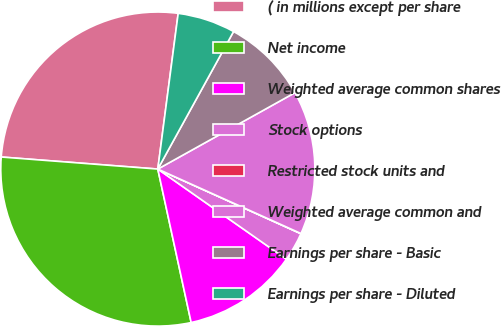Convert chart to OTSL. <chart><loc_0><loc_0><loc_500><loc_500><pie_chart><fcel>( in millions except per share<fcel>Net income<fcel>Weighted average common shares<fcel>Stock options<fcel>Restricted stock units and<fcel>Weighted average common and<fcel>Earnings per share - Basic<fcel>Earnings per share - Diluted<nl><fcel>25.85%<fcel>29.63%<fcel>11.86%<fcel>2.98%<fcel>0.02%<fcel>14.82%<fcel>8.9%<fcel>5.94%<nl></chart> 